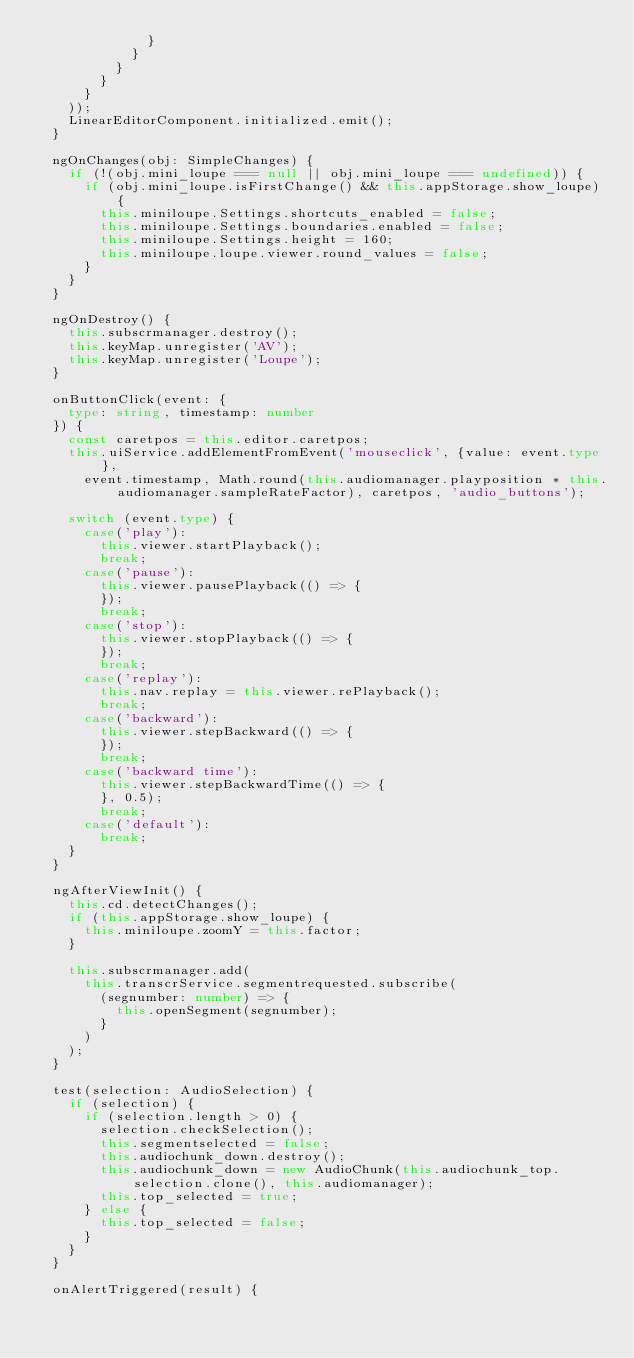<code> <loc_0><loc_0><loc_500><loc_500><_TypeScript_>              }
            }
          }
        }
      }
    ));
    LinearEditorComponent.initialized.emit();
  }

  ngOnChanges(obj: SimpleChanges) {
    if (!(obj.mini_loupe === null || obj.mini_loupe === undefined)) {
      if (obj.mini_loupe.isFirstChange() && this.appStorage.show_loupe) {
        this.miniloupe.Settings.shortcuts_enabled = false;
        this.miniloupe.Settings.boundaries.enabled = false;
        this.miniloupe.Settings.height = 160;
        this.miniloupe.loupe.viewer.round_values = false;
      }
    }
  }

  ngOnDestroy() {
    this.subscrmanager.destroy();
    this.keyMap.unregister('AV');
    this.keyMap.unregister('Loupe');
  }

  onButtonClick(event: {
    type: string, timestamp: number
  }) {
    const caretpos = this.editor.caretpos;
    this.uiService.addElementFromEvent('mouseclick', {value: event.type},
      event.timestamp, Math.round(this.audiomanager.playposition * this.audiomanager.sampleRateFactor), caretpos, 'audio_buttons');

    switch (event.type) {
      case('play'):
        this.viewer.startPlayback();
        break;
      case('pause'):
        this.viewer.pausePlayback(() => {
        });
        break;
      case('stop'):
        this.viewer.stopPlayback(() => {
        });
        break;
      case('replay'):
        this.nav.replay = this.viewer.rePlayback();
        break;
      case('backward'):
        this.viewer.stepBackward(() => {
        });
        break;
      case('backward time'):
        this.viewer.stepBackwardTime(() => {
        }, 0.5);
        break;
      case('default'):
        break;
    }
  }

  ngAfterViewInit() {
    this.cd.detectChanges();
    if (this.appStorage.show_loupe) {
      this.miniloupe.zoomY = this.factor;
    }

    this.subscrmanager.add(
      this.transcrService.segmentrequested.subscribe(
        (segnumber: number) => {
          this.openSegment(segnumber);
        }
      )
    );
  }

  test(selection: AudioSelection) {
    if (selection) {
      if (selection.length > 0) {
        selection.checkSelection();
        this.segmentselected = false;
        this.audiochunk_down.destroy();
        this.audiochunk_down = new AudioChunk(this.audiochunk_top.selection.clone(), this.audiomanager);
        this.top_selected = true;
      } else {
        this.top_selected = false;
      }
    }
  }

  onAlertTriggered(result) {</code> 